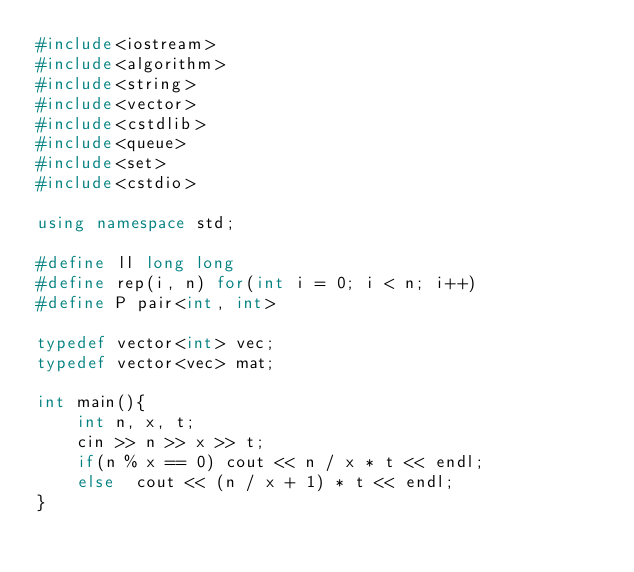<code> <loc_0><loc_0><loc_500><loc_500><_C++_>#include<iostream>
#include<algorithm>
#include<string>
#include<vector>
#include<cstdlib>
#include<queue>
#include<set>
#include<cstdio>

using namespace std;

#define ll long long
#define rep(i, n) for(int i = 0; i < n; i++)
#define P pair<int, int>

typedef vector<int> vec;
typedef vector<vec> mat;

int main(){
    int n, x, t;
    cin >> n >> x >> t;
    if(n % x == 0) cout << n / x * t << endl;
    else  cout << (n / x + 1) * t << endl;
}</code> 